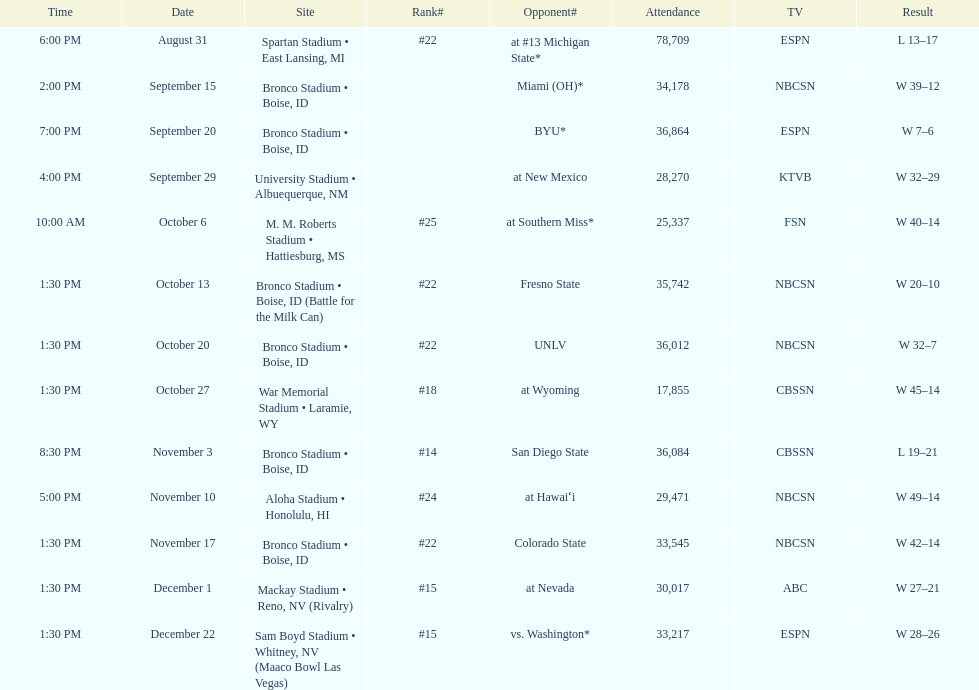What was the most consecutive wins for the team shown in the season? 7. 